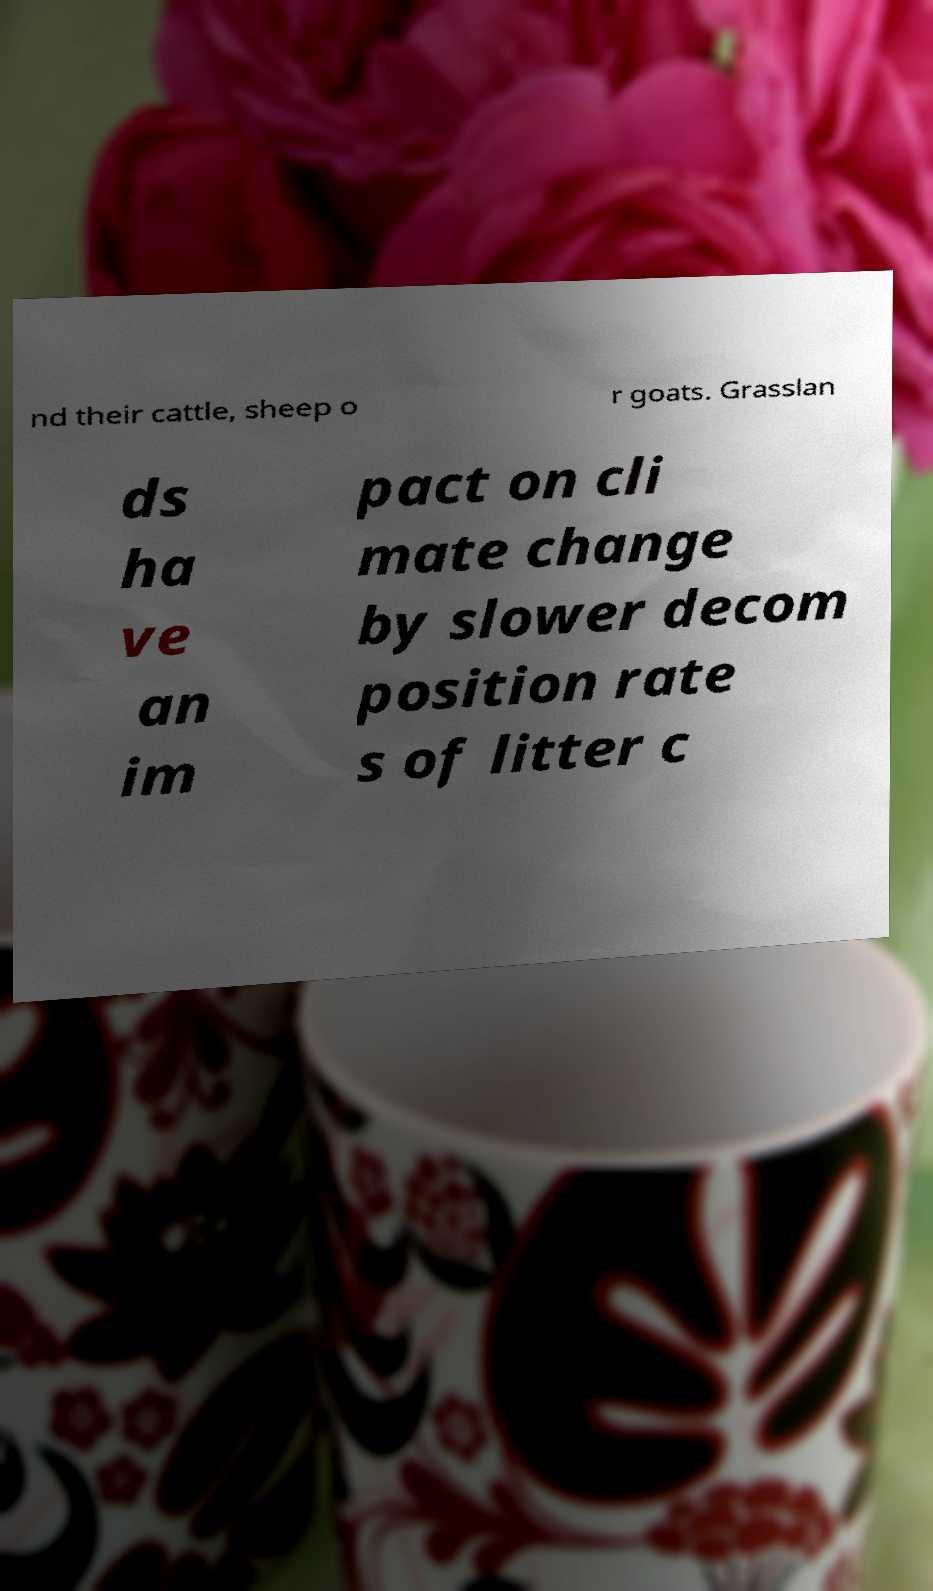Please read and relay the text visible in this image. What does it say? nd their cattle, sheep o r goats. Grasslan ds ha ve an im pact on cli mate change by slower decom position rate s of litter c 